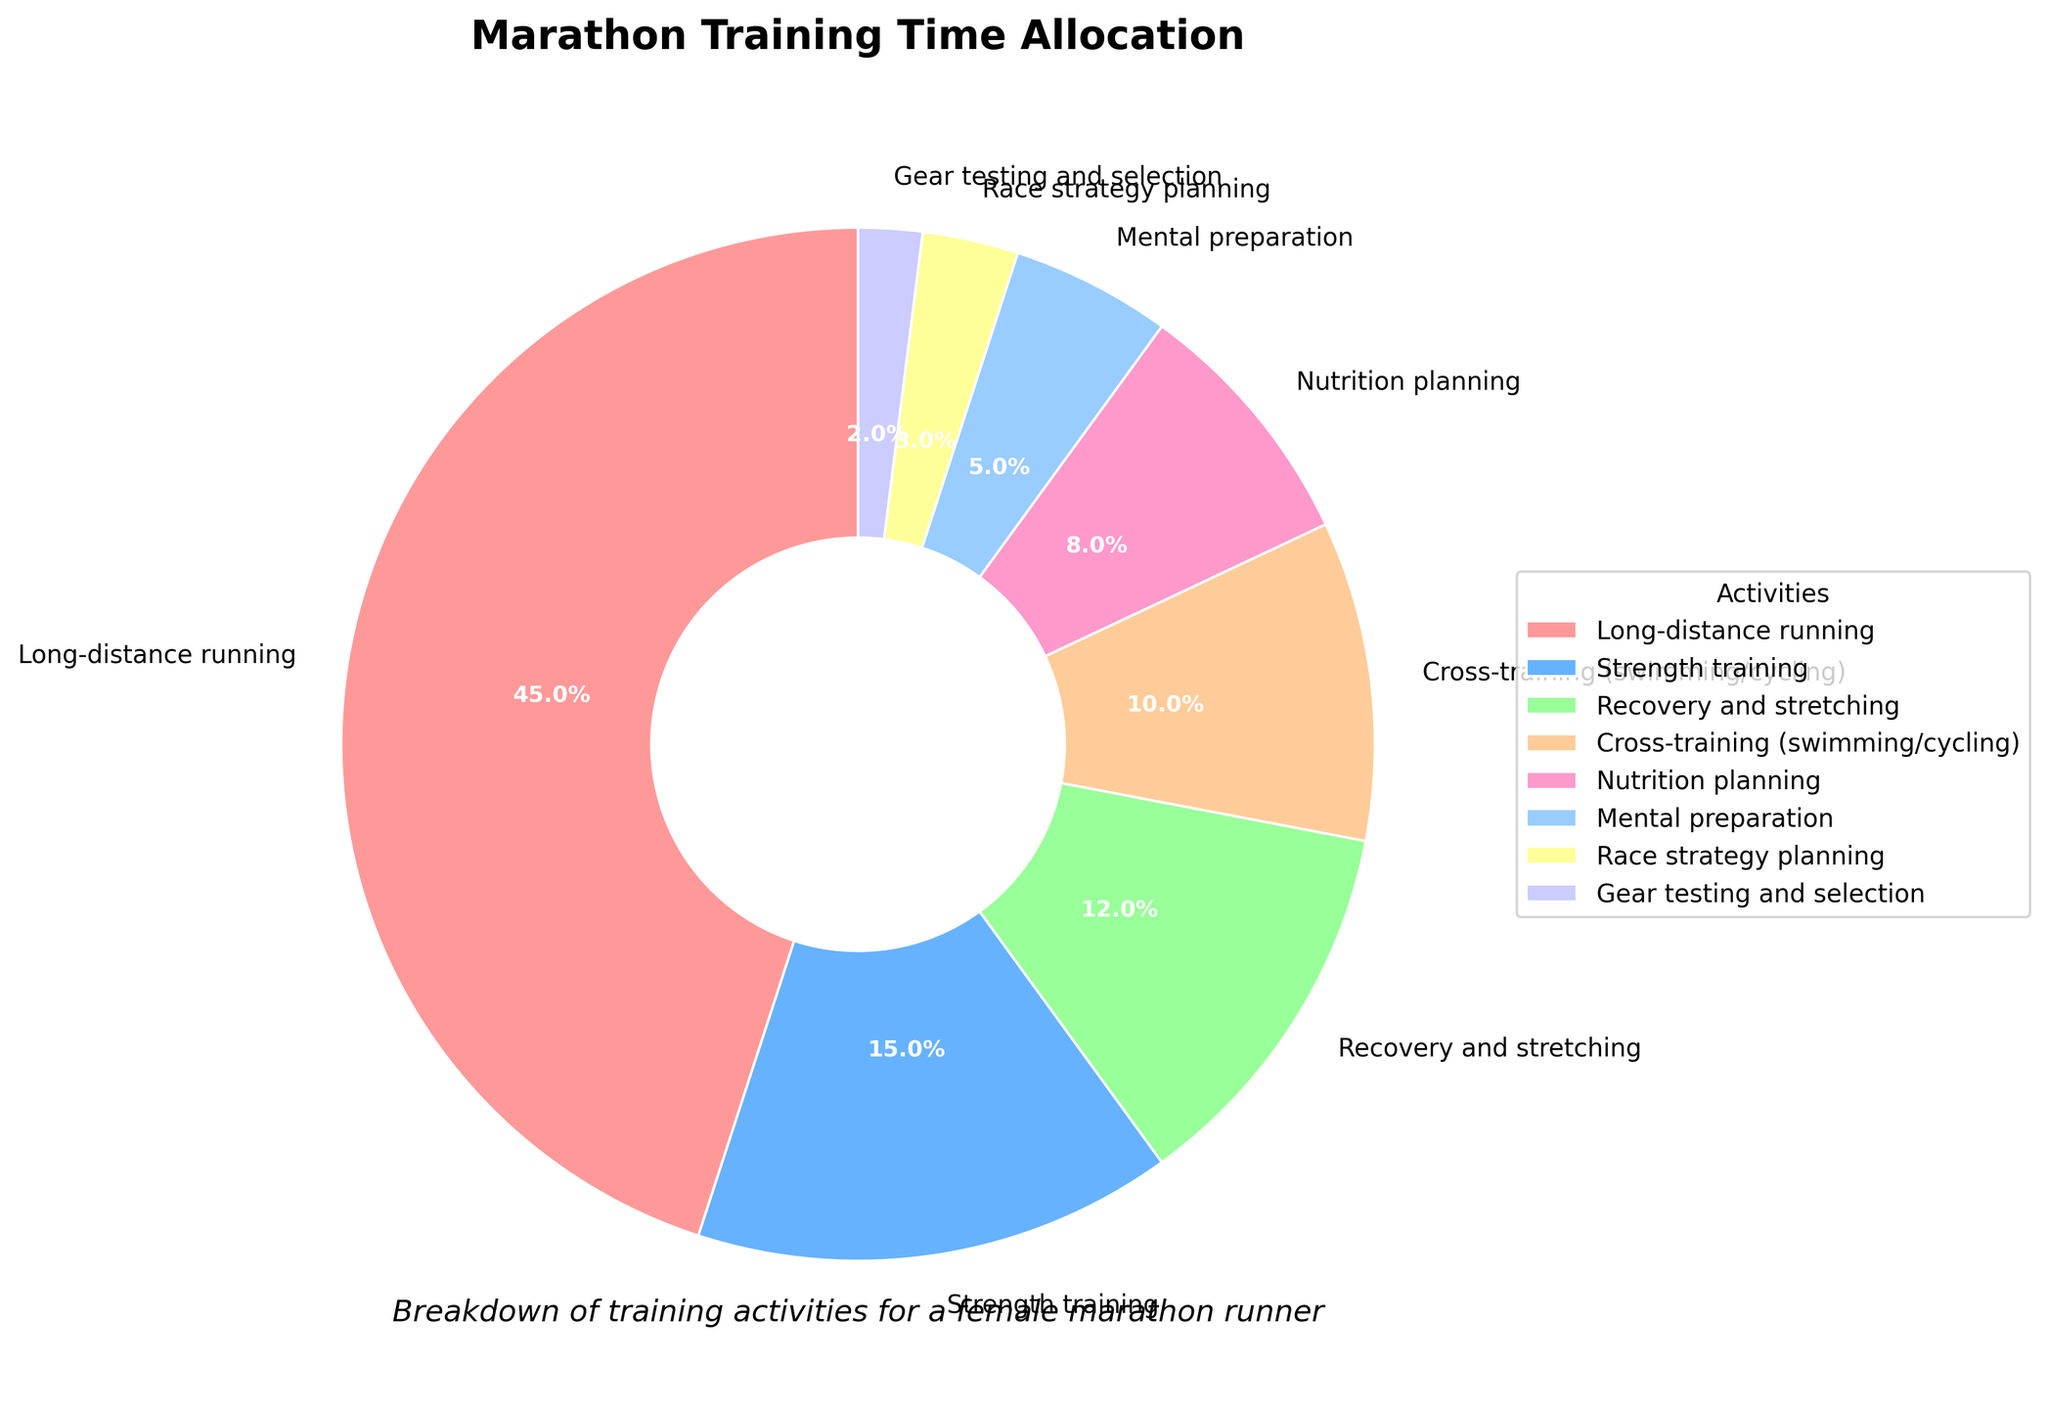Which activity consumes the largest portion of training time? The wedge indicating "Long-distance running" is the largest and is labeled with 45%.
Answer: Long-distance running Which activity uses the smallest amount of training time? The wedge indicating "Gear testing and selection" is the smallest and is labeled with 2%.
Answer: Gear testing and selection How much more training time is allocated to strength training compared to mental preparation? The percentage for strength training is 15%, and for mental preparation, it is 5%. The difference is 15% - 5% = 10%.
Answer: 10% What is the combined percentage of time spent on recovery and stretching, and cross-training? The percentage for recovery and stretching is 12%, and for cross-training, it is 10%. The sum is 12% + 10% = 22%.
Answer: 22% Is the time allocated to race strategy planning greater than to gear testing and selection? The percentage for race strategy planning is 3%, while for gear testing and selection, it is 2%. Since 3% > 2%, yes, more time is allocated to race strategy planning.
Answer: Yes Which activities have a training time allocation of less than 10%? The wedges labeled with percentages less than 10% are: Nutrition planning (8%), Mental preparation (5%), Race strategy planning (3%), and Gear testing and selection (2%).
Answer: Nutrition planning, Mental preparation, Race strategy planning, Gear testing and selection How does the time spent on nutrition planning compare to the time spent on cross-training? The percentage for nutrition planning is 8%, and for cross-training, it is 10%. Cross-training takes 2% more time than nutrition planning.
Answer: Cross-training takes 2% more time What is the total percentage of time allocated to training activities other than long-distance running? The total percentage is the sum of all activities except long-distance running: 15% (Strength training) + 12% (Recovery and stretching) + 10% (Cross-training) + 8% (Nutrition planning) + 5% (Mental preparation) + 3% (Race strategy planning) + 2% (Gear testing and selection) = 55%.
Answer: 55% Which has a larger training time, mental preparation or nutrition planning, and by how much? Nutrition planning has 8% while mental preparation has 5%. The difference is 8% - 5% = 3%.
Answer: Nutrition planning by 3% What is the sum of the percentages of the three largest training activities? The three largest activities are Long-distance running (45%), Strength training (15%), and Recovery and stretching (12%). The sum is 45% + 15% + 12% = 72%.
Answer: 72% 